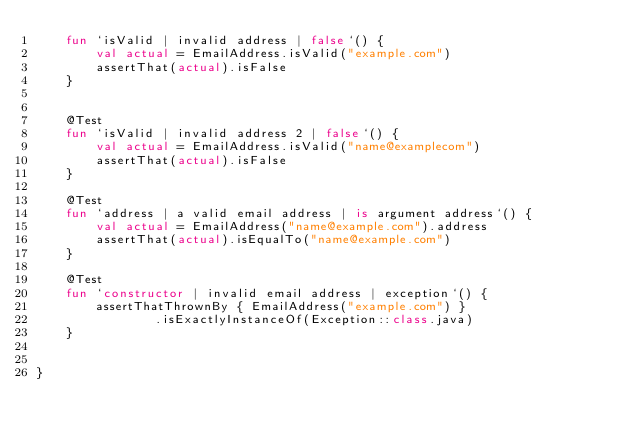<code> <loc_0><loc_0><loc_500><loc_500><_Kotlin_>    fun `isValid | invalid address | false`() {
        val actual = EmailAddress.isValid("example.com")
        assertThat(actual).isFalse
    }


    @Test
    fun `isValid | invalid address 2 | false`() {
        val actual = EmailAddress.isValid("name@examplecom")
        assertThat(actual).isFalse
    }

    @Test
    fun `address | a valid email address | is argument address`() {
        val actual = EmailAddress("name@example.com").address
        assertThat(actual).isEqualTo("name@example.com")
    }

    @Test
    fun `constructor | invalid email address | exception`() {
        assertThatThrownBy { EmailAddress("example.com") }
                .isExactlyInstanceOf(Exception::class.java)
    }


}</code> 